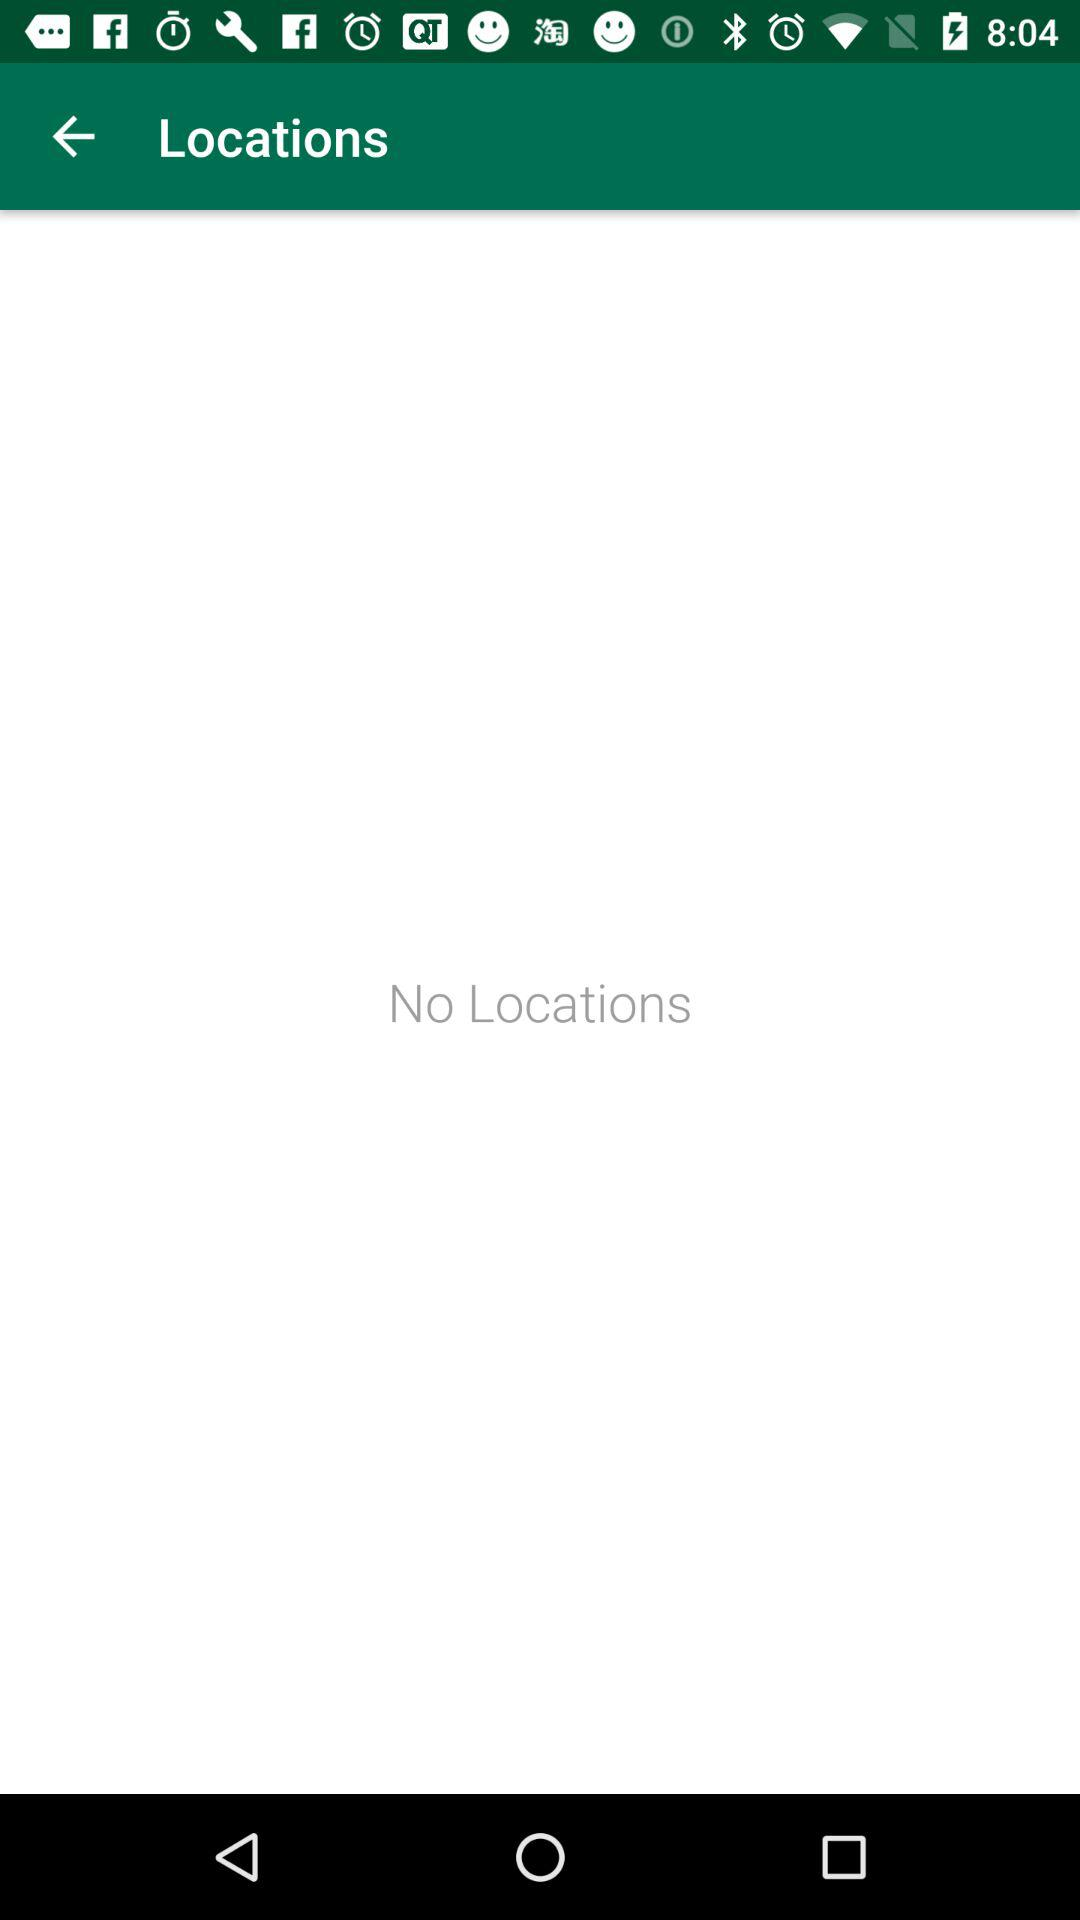Is there any location? There is no location. 